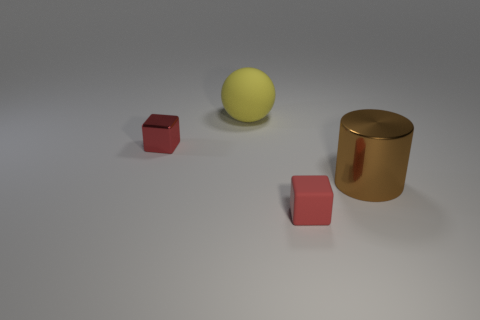What is the shape of the small metal object that is the same color as the rubber cube?
Provide a short and direct response. Cube. What number of big objects are both to the left of the metallic cylinder and in front of the large rubber ball?
Offer a very short reply. 0. What number of other objects are the same size as the yellow matte ball?
Give a very brief answer. 1. Is the shape of the metal thing left of the red rubber cube the same as the big object that is to the left of the brown metallic cylinder?
Keep it short and to the point. No. Are there any brown shiny objects in front of the small red matte object?
Ensure brevity in your answer.  No. There is another thing that is the same shape as the small red matte thing; what is its color?
Offer a terse response. Red. Are there any other things that have the same shape as the red metal thing?
Your response must be concise. Yes. What is the large brown thing that is in front of the yellow sphere made of?
Give a very brief answer. Metal. There is a metal object that is the same shape as the red rubber object; what size is it?
Make the answer very short. Small. What number of objects have the same material as the big brown cylinder?
Your answer should be compact. 1. 